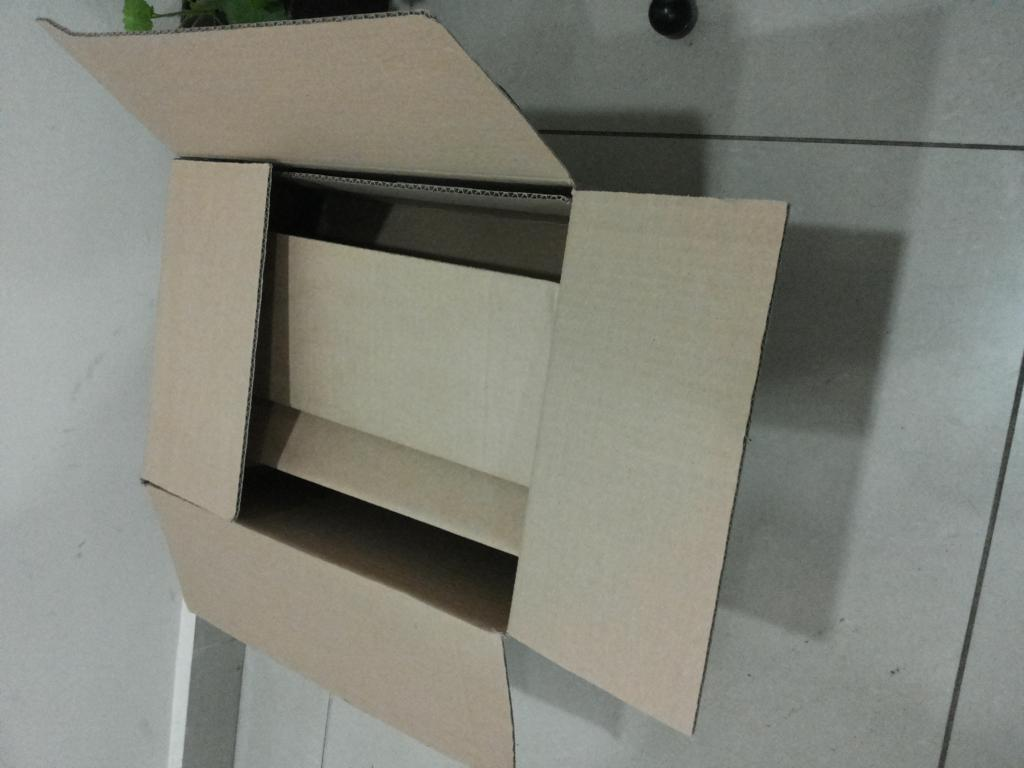What object is on the floor in the image? There is a box on the floor in the image. What can be seen in the background of the image? There is a wall in the background of the image. Where is the market located in the image? There is no market present in the image; it only features a box on the floor and a wall in the background. 